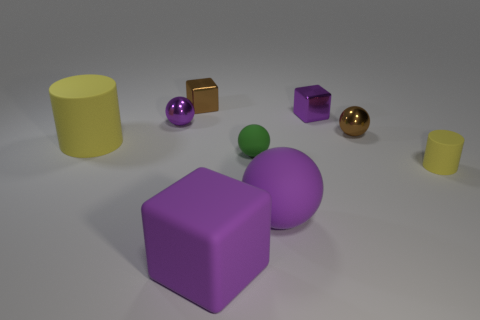Subtract all brown spheres. How many spheres are left? 3 Add 1 large purple balls. How many objects exist? 10 Subtract all yellow balls. Subtract all green cylinders. How many balls are left? 4 Subtract all cylinders. How many objects are left? 7 Subtract all shiny cubes. Subtract all green things. How many objects are left? 6 Add 1 small brown things. How many small brown things are left? 3 Add 2 brown metallic things. How many brown metallic things exist? 4 Subtract 0 cyan cylinders. How many objects are left? 9 